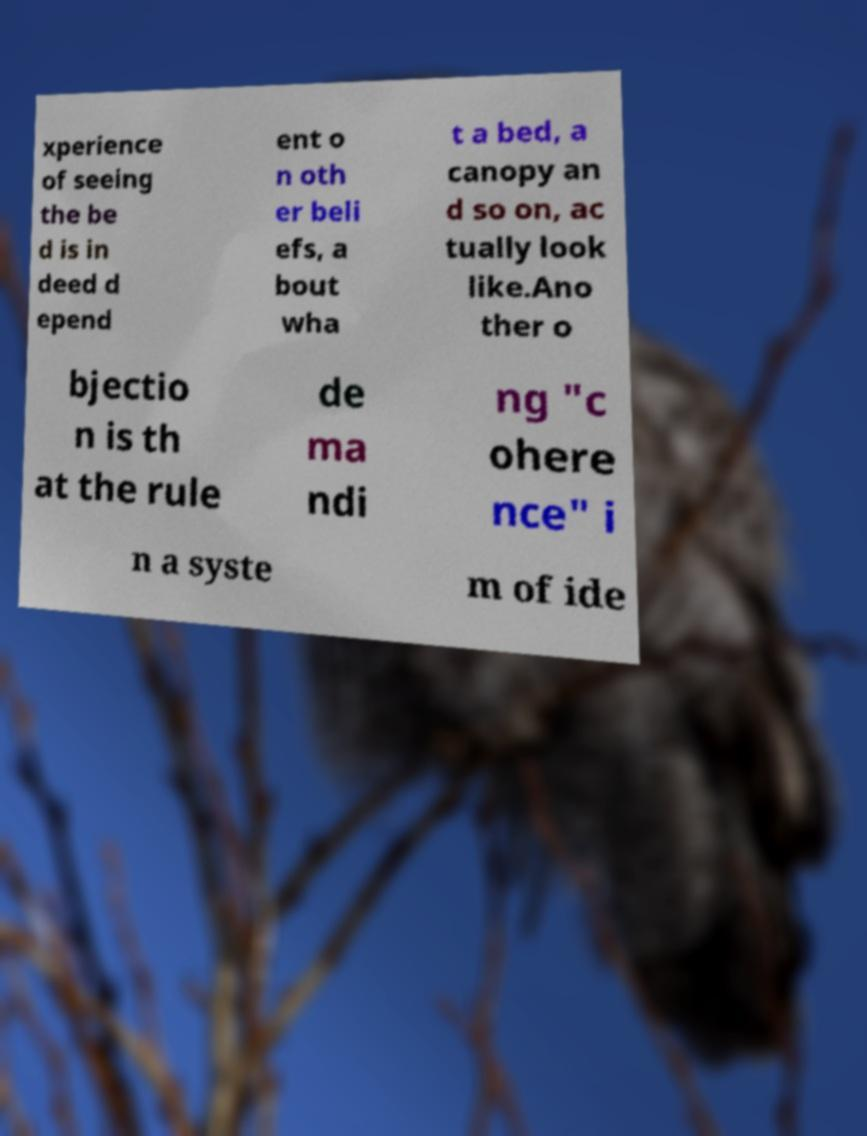For documentation purposes, I need the text within this image transcribed. Could you provide that? xperience of seeing the be d is in deed d epend ent o n oth er beli efs, a bout wha t a bed, a canopy an d so on, ac tually look like.Ano ther o bjectio n is th at the rule de ma ndi ng "c ohere nce" i n a syste m of ide 